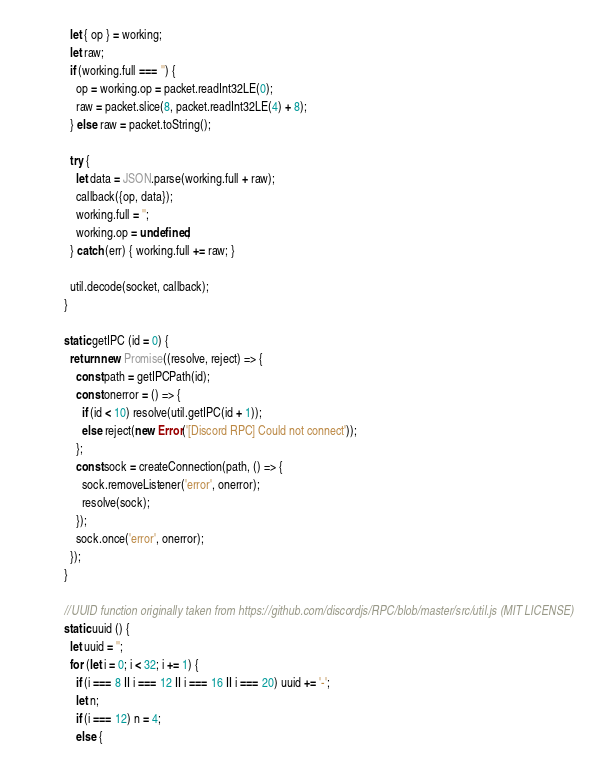<code> <loc_0><loc_0><loc_500><loc_500><_JavaScript_>    let { op } = working;
    let raw;
    if (working.full === '') {
      op = working.op = packet.readInt32LE(0);
      raw = packet.slice(8, packet.readInt32LE(4) + 8);
    } else raw = packet.toString();

    try {
      let data = JSON.parse(working.full + raw);
      callback({op, data});
      working.full = '';
      working.op = undefined;
    } catch (err) { working.full += raw; }

    util.decode(socket, callback);
  }

  static getIPC (id = 0) {
    return new Promise((resolve, reject) => {
      const path = getIPCPath(id);
      const onerror = () => {
        if (id < 10) resolve(util.getIPC(id + 1));
        else reject(new Error('[Discord RPC] Could not connect'));
      };
      const sock = createConnection(path, () => {
        sock.removeListener('error', onerror);
        resolve(sock);
      });
      sock.once('error', onerror);
    });
  }

  //UUID function originally taken from https://github.com/discordjs/RPC/blob/master/src/util.js (MIT LICENSE)
  static uuid () {
    let uuid = '';
    for (let i = 0; i < 32; i += 1) {
      if (i === 8 || i === 12 || i === 16 || i === 20) uuid += '-';
      let n;
      if (i === 12) n = 4;
      else {</code> 